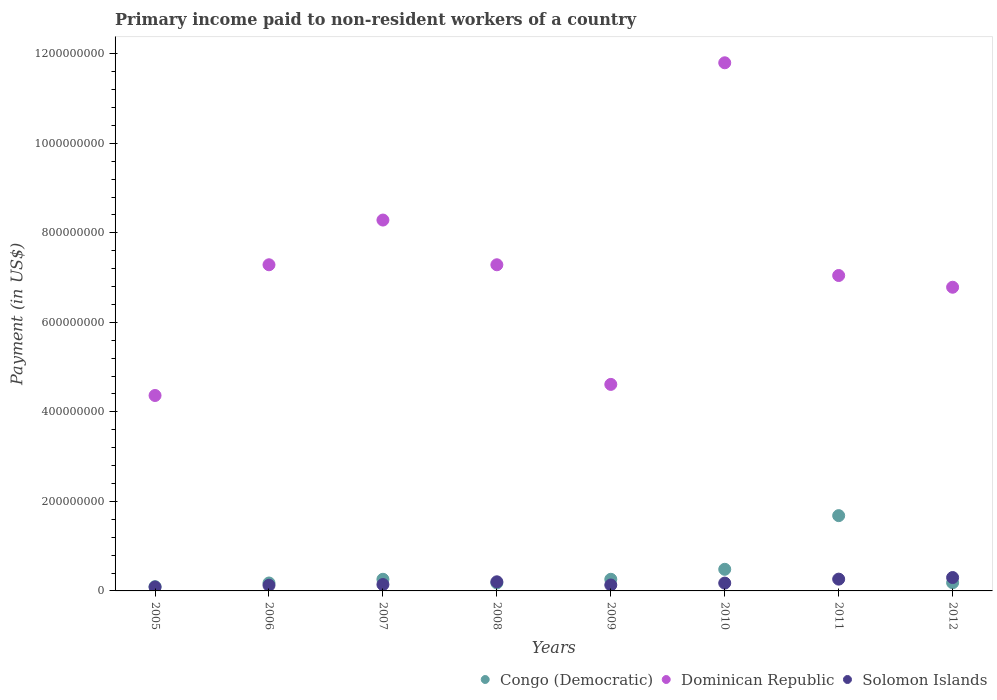How many different coloured dotlines are there?
Your answer should be very brief. 3. Is the number of dotlines equal to the number of legend labels?
Keep it short and to the point. Yes. What is the amount paid to workers in Dominican Republic in 2009?
Provide a short and direct response. 4.61e+08. Across all years, what is the maximum amount paid to workers in Dominican Republic?
Your answer should be very brief. 1.18e+09. Across all years, what is the minimum amount paid to workers in Congo (Democratic)?
Keep it short and to the point. 9.50e+06. In which year was the amount paid to workers in Solomon Islands minimum?
Ensure brevity in your answer.  2005. What is the total amount paid to workers in Dominican Republic in the graph?
Provide a short and direct response. 5.75e+09. What is the difference between the amount paid to workers in Solomon Islands in 2005 and that in 2011?
Offer a very short reply. -1.76e+07. What is the difference between the amount paid to workers in Congo (Democratic) in 2005 and the amount paid to workers in Dominican Republic in 2007?
Provide a short and direct response. -8.19e+08. What is the average amount paid to workers in Congo (Democratic) per year?
Make the answer very short. 4.15e+07. In the year 2009, what is the difference between the amount paid to workers in Solomon Islands and amount paid to workers in Dominican Republic?
Give a very brief answer. -4.48e+08. In how many years, is the amount paid to workers in Dominican Republic greater than 880000000 US$?
Offer a terse response. 1. What is the ratio of the amount paid to workers in Congo (Democratic) in 2009 to that in 2012?
Offer a very short reply. 1.42. Is the difference between the amount paid to workers in Solomon Islands in 2006 and 2007 greater than the difference between the amount paid to workers in Dominican Republic in 2006 and 2007?
Provide a succinct answer. Yes. What is the difference between the highest and the second highest amount paid to workers in Dominican Republic?
Keep it short and to the point. 3.51e+08. What is the difference between the highest and the lowest amount paid to workers in Dominican Republic?
Offer a terse response. 7.43e+08. Is the sum of the amount paid to workers in Dominican Republic in 2011 and 2012 greater than the maximum amount paid to workers in Solomon Islands across all years?
Make the answer very short. Yes. Does the amount paid to workers in Congo (Democratic) monotonically increase over the years?
Ensure brevity in your answer.  No. Is the amount paid to workers in Dominican Republic strictly greater than the amount paid to workers in Solomon Islands over the years?
Provide a short and direct response. Yes. Is the amount paid to workers in Dominican Republic strictly less than the amount paid to workers in Congo (Democratic) over the years?
Your response must be concise. No. How many dotlines are there?
Keep it short and to the point. 3. What is the difference between two consecutive major ticks on the Y-axis?
Keep it short and to the point. 2.00e+08. Does the graph contain any zero values?
Your answer should be compact. No. Where does the legend appear in the graph?
Your answer should be very brief. Bottom right. How many legend labels are there?
Your answer should be very brief. 3. How are the legend labels stacked?
Your answer should be very brief. Horizontal. What is the title of the graph?
Your answer should be compact. Primary income paid to non-resident workers of a country. Does "Gabon" appear as one of the legend labels in the graph?
Provide a succinct answer. No. What is the label or title of the X-axis?
Ensure brevity in your answer.  Years. What is the label or title of the Y-axis?
Ensure brevity in your answer.  Payment (in US$). What is the Payment (in US$) of Congo (Democratic) in 2005?
Make the answer very short. 9.50e+06. What is the Payment (in US$) of Dominican Republic in 2005?
Give a very brief answer. 4.37e+08. What is the Payment (in US$) in Solomon Islands in 2005?
Provide a short and direct response. 8.69e+06. What is the Payment (in US$) in Congo (Democratic) in 2006?
Provide a short and direct response. 1.77e+07. What is the Payment (in US$) of Dominican Republic in 2006?
Offer a terse response. 7.29e+08. What is the Payment (in US$) of Solomon Islands in 2006?
Your response must be concise. 1.26e+07. What is the Payment (in US$) of Congo (Democratic) in 2007?
Offer a very short reply. 2.60e+07. What is the Payment (in US$) in Dominican Republic in 2007?
Offer a very short reply. 8.29e+08. What is the Payment (in US$) of Solomon Islands in 2007?
Ensure brevity in your answer.  1.43e+07. What is the Payment (in US$) in Congo (Democratic) in 2008?
Keep it short and to the point. 1.78e+07. What is the Payment (in US$) of Dominican Republic in 2008?
Provide a succinct answer. 7.29e+08. What is the Payment (in US$) of Solomon Islands in 2008?
Provide a succinct answer. 2.04e+07. What is the Payment (in US$) in Congo (Democratic) in 2009?
Give a very brief answer. 2.60e+07. What is the Payment (in US$) of Dominican Republic in 2009?
Provide a succinct answer. 4.61e+08. What is the Payment (in US$) in Solomon Islands in 2009?
Keep it short and to the point. 1.32e+07. What is the Payment (in US$) in Congo (Democratic) in 2010?
Your response must be concise. 4.83e+07. What is the Payment (in US$) in Dominican Republic in 2010?
Offer a terse response. 1.18e+09. What is the Payment (in US$) of Solomon Islands in 2010?
Make the answer very short. 1.75e+07. What is the Payment (in US$) of Congo (Democratic) in 2011?
Your response must be concise. 1.68e+08. What is the Payment (in US$) in Dominican Republic in 2011?
Ensure brevity in your answer.  7.05e+08. What is the Payment (in US$) in Solomon Islands in 2011?
Your answer should be very brief. 2.63e+07. What is the Payment (in US$) of Congo (Democratic) in 2012?
Offer a terse response. 1.83e+07. What is the Payment (in US$) in Dominican Republic in 2012?
Provide a succinct answer. 6.78e+08. What is the Payment (in US$) in Solomon Islands in 2012?
Ensure brevity in your answer.  2.99e+07. Across all years, what is the maximum Payment (in US$) in Congo (Democratic)?
Give a very brief answer. 1.68e+08. Across all years, what is the maximum Payment (in US$) of Dominican Republic?
Give a very brief answer. 1.18e+09. Across all years, what is the maximum Payment (in US$) in Solomon Islands?
Offer a terse response. 2.99e+07. Across all years, what is the minimum Payment (in US$) of Congo (Democratic)?
Make the answer very short. 9.50e+06. Across all years, what is the minimum Payment (in US$) of Dominican Republic?
Offer a terse response. 4.37e+08. Across all years, what is the minimum Payment (in US$) of Solomon Islands?
Make the answer very short. 8.69e+06. What is the total Payment (in US$) in Congo (Democratic) in the graph?
Ensure brevity in your answer.  3.32e+08. What is the total Payment (in US$) in Dominican Republic in the graph?
Provide a succinct answer. 5.75e+09. What is the total Payment (in US$) of Solomon Islands in the graph?
Your response must be concise. 1.43e+08. What is the difference between the Payment (in US$) in Congo (Democratic) in 2005 and that in 2006?
Keep it short and to the point. -8.20e+06. What is the difference between the Payment (in US$) of Dominican Republic in 2005 and that in 2006?
Offer a terse response. -2.92e+08. What is the difference between the Payment (in US$) of Solomon Islands in 2005 and that in 2006?
Your response must be concise. -3.88e+06. What is the difference between the Payment (in US$) of Congo (Democratic) in 2005 and that in 2007?
Offer a terse response. -1.65e+07. What is the difference between the Payment (in US$) in Dominican Republic in 2005 and that in 2007?
Offer a terse response. -3.92e+08. What is the difference between the Payment (in US$) in Solomon Islands in 2005 and that in 2007?
Provide a short and direct response. -5.57e+06. What is the difference between the Payment (in US$) of Congo (Democratic) in 2005 and that in 2008?
Make the answer very short. -8.30e+06. What is the difference between the Payment (in US$) of Dominican Republic in 2005 and that in 2008?
Keep it short and to the point. -2.92e+08. What is the difference between the Payment (in US$) of Solomon Islands in 2005 and that in 2008?
Offer a terse response. -1.17e+07. What is the difference between the Payment (in US$) of Congo (Democratic) in 2005 and that in 2009?
Keep it short and to the point. -1.65e+07. What is the difference between the Payment (in US$) in Dominican Republic in 2005 and that in 2009?
Provide a short and direct response. -2.48e+07. What is the difference between the Payment (in US$) in Solomon Islands in 2005 and that in 2009?
Provide a succinct answer. -4.55e+06. What is the difference between the Payment (in US$) of Congo (Democratic) in 2005 and that in 2010?
Provide a short and direct response. -3.88e+07. What is the difference between the Payment (in US$) of Dominican Republic in 2005 and that in 2010?
Your answer should be very brief. -7.43e+08. What is the difference between the Payment (in US$) of Solomon Islands in 2005 and that in 2010?
Provide a succinct answer. -8.81e+06. What is the difference between the Payment (in US$) in Congo (Democratic) in 2005 and that in 2011?
Give a very brief answer. -1.59e+08. What is the difference between the Payment (in US$) of Dominican Republic in 2005 and that in 2011?
Keep it short and to the point. -2.68e+08. What is the difference between the Payment (in US$) of Solomon Islands in 2005 and that in 2011?
Provide a succinct answer. -1.76e+07. What is the difference between the Payment (in US$) of Congo (Democratic) in 2005 and that in 2012?
Keep it short and to the point. -8.76e+06. What is the difference between the Payment (in US$) of Dominican Republic in 2005 and that in 2012?
Your answer should be compact. -2.42e+08. What is the difference between the Payment (in US$) of Solomon Islands in 2005 and that in 2012?
Ensure brevity in your answer.  -2.12e+07. What is the difference between the Payment (in US$) in Congo (Democratic) in 2006 and that in 2007?
Give a very brief answer. -8.30e+06. What is the difference between the Payment (in US$) of Dominican Republic in 2006 and that in 2007?
Provide a succinct answer. -9.99e+07. What is the difference between the Payment (in US$) of Solomon Islands in 2006 and that in 2007?
Make the answer very short. -1.69e+06. What is the difference between the Payment (in US$) in Solomon Islands in 2006 and that in 2008?
Your answer should be very brief. -7.80e+06. What is the difference between the Payment (in US$) in Congo (Democratic) in 2006 and that in 2009?
Offer a terse response. -8.30e+06. What is the difference between the Payment (in US$) of Dominican Republic in 2006 and that in 2009?
Offer a terse response. 2.67e+08. What is the difference between the Payment (in US$) of Solomon Islands in 2006 and that in 2009?
Give a very brief answer. -6.69e+05. What is the difference between the Payment (in US$) in Congo (Democratic) in 2006 and that in 2010?
Your answer should be very brief. -3.06e+07. What is the difference between the Payment (in US$) of Dominican Republic in 2006 and that in 2010?
Offer a terse response. -4.51e+08. What is the difference between the Payment (in US$) in Solomon Islands in 2006 and that in 2010?
Provide a succinct answer. -4.93e+06. What is the difference between the Payment (in US$) of Congo (Democratic) in 2006 and that in 2011?
Keep it short and to the point. -1.50e+08. What is the difference between the Payment (in US$) of Dominican Republic in 2006 and that in 2011?
Provide a succinct answer. 2.40e+07. What is the difference between the Payment (in US$) of Solomon Islands in 2006 and that in 2011?
Give a very brief answer. -1.38e+07. What is the difference between the Payment (in US$) of Congo (Democratic) in 2006 and that in 2012?
Give a very brief answer. -5.62e+05. What is the difference between the Payment (in US$) of Dominican Republic in 2006 and that in 2012?
Give a very brief answer. 5.02e+07. What is the difference between the Payment (in US$) in Solomon Islands in 2006 and that in 2012?
Keep it short and to the point. -1.73e+07. What is the difference between the Payment (in US$) of Congo (Democratic) in 2007 and that in 2008?
Your answer should be very brief. 8.20e+06. What is the difference between the Payment (in US$) of Dominican Republic in 2007 and that in 2008?
Offer a very short reply. 9.99e+07. What is the difference between the Payment (in US$) of Solomon Islands in 2007 and that in 2008?
Make the answer very short. -6.11e+06. What is the difference between the Payment (in US$) of Congo (Democratic) in 2007 and that in 2009?
Keep it short and to the point. 0. What is the difference between the Payment (in US$) in Dominican Republic in 2007 and that in 2009?
Your response must be concise. 3.67e+08. What is the difference between the Payment (in US$) of Solomon Islands in 2007 and that in 2009?
Your answer should be compact. 1.02e+06. What is the difference between the Payment (in US$) in Congo (Democratic) in 2007 and that in 2010?
Make the answer very short. -2.23e+07. What is the difference between the Payment (in US$) of Dominican Republic in 2007 and that in 2010?
Your response must be concise. -3.51e+08. What is the difference between the Payment (in US$) in Solomon Islands in 2007 and that in 2010?
Your answer should be very brief. -3.24e+06. What is the difference between the Payment (in US$) of Congo (Democratic) in 2007 and that in 2011?
Offer a very short reply. -1.42e+08. What is the difference between the Payment (in US$) of Dominican Republic in 2007 and that in 2011?
Make the answer very short. 1.24e+08. What is the difference between the Payment (in US$) of Solomon Islands in 2007 and that in 2011?
Provide a short and direct response. -1.21e+07. What is the difference between the Payment (in US$) of Congo (Democratic) in 2007 and that in 2012?
Ensure brevity in your answer.  7.74e+06. What is the difference between the Payment (in US$) in Dominican Republic in 2007 and that in 2012?
Your response must be concise. 1.50e+08. What is the difference between the Payment (in US$) of Solomon Islands in 2007 and that in 2012?
Give a very brief answer. -1.56e+07. What is the difference between the Payment (in US$) in Congo (Democratic) in 2008 and that in 2009?
Ensure brevity in your answer.  -8.20e+06. What is the difference between the Payment (in US$) in Dominican Republic in 2008 and that in 2009?
Keep it short and to the point. 2.67e+08. What is the difference between the Payment (in US$) in Solomon Islands in 2008 and that in 2009?
Make the answer very short. 7.13e+06. What is the difference between the Payment (in US$) of Congo (Democratic) in 2008 and that in 2010?
Offer a terse response. -3.05e+07. What is the difference between the Payment (in US$) of Dominican Republic in 2008 and that in 2010?
Your answer should be very brief. -4.51e+08. What is the difference between the Payment (in US$) of Solomon Islands in 2008 and that in 2010?
Give a very brief answer. 2.87e+06. What is the difference between the Payment (in US$) in Congo (Democratic) in 2008 and that in 2011?
Your answer should be very brief. -1.50e+08. What is the difference between the Payment (in US$) of Dominican Republic in 2008 and that in 2011?
Provide a short and direct response. 2.40e+07. What is the difference between the Payment (in US$) of Solomon Islands in 2008 and that in 2011?
Keep it short and to the point. -5.95e+06. What is the difference between the Payment (in US$) in Congo (Democratic) in 2008 and that in 2012?
Your response must be concise. -4.62e+05. What is the difference between the Payment (in US$) of Dominican Republic in 2008 and that in 2012?
Your response must be concise. 5.02e+07. What is the difference between the Payment (in US$) in Solomon Islands in 2008 and that in 2012?
Give a very brief answer. -9.53e+06. What is the difference between the Payment (in US$) of Congo (Democratic) in 2009 and that in 2010?
Provide a short and direct response. -2.23e+07. What is the difference between the Payment (in US$) of Dominican Republic in 2009 and that in 2010?
Your answer should be compact. -7.19e+08. What is the difference between the Payment (in US$) of Solomon Islands in 2009 and that in 2010?
Ensure brevity in your answer.  -4.26e+06. What is the difference between the Payment (in US$) in Congo (Democratic) in 2009 and that in 2011?
Your answer should be very brief. -1.42e+08. What is the difference between the Payment (in US$) of Dominican Republic in 2009 and that in 2011?
Give a very brief answer. -2.43e+08. What is the difference between the Payment (in US$) of Solomon Islands in 2009 and that in 2011?
Keep it short and to the point. -1.31e+07. What is the difference between the Payment (in US$) of Congo (Democratic) in 2009 and that in 2012?
Offer a terse response. 7.74e+06. What is the difference between the Payment (in US$) in Dominican Republic in 2009 and that in 2012?
Offer a terse response. -2.17e+08. What is the difference between the Payment (in US$) in Solomon Islands in 2009 and that in 2012?
Give a very brief answer. -1.67e+07. What is the difference between the Payment (in US$) in Congo (Democratic) in 2010 and that in 2011?
Ensure brevity in your answer.  -1.20e+08. What is the difference between the Payment (in US$) in Dominican Republic in 2010 and that in 2011?
Offer a very short reply. 4.75e+08. What is the difference between the Payment (in US$) in Solomon Islands in 2010 and that in 2011?
Give a very brief answer. -8.82e+06. What is the difference between the Payment (in US$) of Congo (Democratic) in 2010 and that in 2012?
Your response must be concise. 3.00e+07. What is the difference between the Payment (in US$) in Dominican Republic in 2010 and that in 2012?
Provide a short and direct response. 5.01e+08. What is the difference between the Payment (in US$) in Solomon Islands in 2010 and that in 2012?
Offer a terse response. -1.24e+07. What is the difference between the Payment (in US$) in Congo (Democratic) in 2011 and that in 2012?
Ensure brevity in your answer.  1.50e+08. What is the difference between the Payment (in US$) of Dominican Republic in 2011 and that in 2012?
Give a very brief answer. 2.62e+07. What is the difference between the Payment (in US$) of Solomon Islands in 2011 and that in 2012?
Offer a terse response. -3.58e+06. What is the difference between the Payment (in US$) in Congo (Democratic) in 2005 and the Payment (in US$) in Dominican Republic in 2006?
Offer a very short reply. -7.19e+08. What is the difference between the Payment (in US$) of Congo (Democratic) in 2005 and the Payment (in US$) of Solomon Islands in 2006?
Offer a very short reply. -3.07e+06. What is the difference between the Payment (in US$) of Dominican Republic in 2005 and the Payment (in US$) of Solomon Islands in 2006?
Ensure brevity in your answer.  4.24e+08. What is the difference between the Payment (in US$) in Congo (Democratic) in 2005 and the Payment (in US$) in Dominican Republic in 2007?
Make the answer very short. -8.19e+08. What is the difference between the Payment (in US$) of Congo (Democratic) in 2005 and the Payment (in US$) of Solomon Islands in 2007?
Provide a short and direct response. -4.77e+06. What is the difference between the Payment (in US$) in Dominican Republic in 2005 and the Payment (in US$) in Solomon Islands in 2007?
Your answer should be compact. 4.22e+08. What is the difference between the Payment (in US$) of Congo (Democratic) in 2005 and the Payment (in US$) of Dominican Republic in 2008?
Keep it short and to the point. -7.19e+08. What is the difference between the Payment (in US$) in Congo (Democratic) in 2005 and the Payment (in US$) in Solomon Islands in 2008?
Your answer should be very brief. -1.09e+07. What is the difference between the Payment (in US$) in Dominican Republic in 2005 and the Payment (in US$) in Solomon Islands in 2008?
Offer a terse response. 4.16e+08. What is the difference between the Payment (in US$) in Congo (Democratic) in 2005 and the Payment (in US$) in Dominican Republic in 2009?
Keep it short and to the point. -4.52e+08. What is the difference between the Payment (in US$) in Congo (Democratic) in 2005 and the Payment (in US$) in Solomon Islands in 2009?
Provide a succinct answer. -3.74e+06. What is the difference between the Payment (in US$) in Dominican Republic in 2005 and the Payment (in US$) in Solomon Islands in 2009?
Your response must be concise. 4.23e+08. What is the difference between the Payment (in US$) in Congo (Democratic) in 2005 and the Payment (in US$) in Dominican Republic in 2010?
Offer a terse response. -1.17e+09. What is the difference between the Payment (in US$) in Congo (Democratic) in 2005 and the Payment (in US$) in Solomon Islands in 2010?
Provide a succinct answer. -8.01e+06. What is the difference between the Payment (in US$) in Dominican Republic in 2005 and the Payment (in US$) in Solomon Islands in 2010?
Keep it short and to the point. 4.19e+08. What is the difference between the Payment (in US$) in Congo (Democratic) in 2005 and the Payment (in US$) in Dominican Republic in 2011?
Ensure brevity in your answer.  -6.95e+08. What is the difference between the Payment (in US$) in Congo (Democratic) in 2005 and the Payment (in US$) in Solomon Islands in 2011?
Make the answer very short. -1.68e+07. What is the difference between the Payment (in US$) in Dominican Republic in 2005 and the Payment (in US$) in Solomon Islands in 2011?
Provide a succinct answer. 4.10e+08. What is the difference between the Payment (in US$) in Congo (Democratic) in 2005 and the Payment (in US$) in Dominican Republic in 2012?
Ensure brevity in your answer.  -6.69e+08. What is the difference between the Payment (in US$) of Congo (Democratic) in 2005 and the Payment (in US$) of Solomon Islands in 2012?
Your response must be concise. -2.04e+07. What is the difference between the Payment (in US$) of Dominican Republic in 2005 and the Payment (in US$) of Solomon Islands in 2012?
Make the answer very short. 4.07e+08. What is the difference between the Payment (in US$) of Congo (Democratic) in 2006 and the Payment (in US$) of Dominican Republic in 2007?
Offer a very short reply. -8.11e+08. What is the difference between the Payment (in US$) in Congo (Democratic) in 2006 and the Payment (in US$) in Solomon Islands in 2007?
Offer a terse response. 3.43e+06. What is the difference between the Payment (in US$) in Dominican Republic in 2006 and the Payment (in US$) in Solomon Islands in 2007?
Give a very brief answer. 7.14e+08. What is the difference between the Payment (in US$) of Congo (Democratic) in 2006 and the Payment (in US$) of Dominican Republic in 2008?
Provide a short and direct response. -7.11e+08. What is the difference between the Payment (in US$) of Congo (Democratic) in 2006 and the Payment (in US$) of Solomon Islands in 2008?
Provide a succinct answer. -2.67e+06. What is the difference between the Payment (in US$) in Dominican Republic in 2006 and the Payment (in US$) in Solomon Islands in 2008?
Give a very brief answer. 7.08e+08. What is the difference between the Payment (in US$) in Congo (Democratic) in 2006 and the Payment (in US$) in Dominican Republic in 2009?
Offer a very short reply. -4.44e+08. What is the difference between the Payment (in US$) of Congo (Democratic) in 2006 and the Payment (in US$) of Solomon Islands in 2009?
Offer a very short reply. 4.46e+06. What is the difference between the Payment (in US$) of Dominican Republic in 2006 and the Payment (in US$) of Solomon Islands in 2009?
Provide a short and direct response. 7.15e+08. What is the difference between the Payment (in US$) in Congo (Democratic) in 2006 and the Payment (in US$) in Dominican Republic in 2010?
Your response must be concise. -1.16e+09. What is the difference between the Payment (in US$) in Congo (Democratic) in 2006 and the Payment (in US$) in Solomon Islands in 2010?
Your answer should be compact. 1.95e+05. What is the difference between the Payment (in US$) of Dominican Republic in 2006 and the Payment (in US$) of Solomon Islands in 2010?
Give a very brief answer. 7.11e+08. What is the difference between the Payment (in US$) in Congo (Democratic) in 2006 and the Payment (in US$) in Dominican Republic in 2011?
Provide a succinct answer. -6.87e+08. What is the difference between the Payment (in US$) in Congo (Democratic) in 2006 and the Payment (in US$) in Solomon Islands in 2011?
Your response must be concise. -8.62e+06. What is the difference between the Payment (in US$) in Dominican Republic in 2006 and the Payment (in US$) in Solomon Islands in 2011?
Provide a succinct answer. 7.02e+08. What is the difference between the Payment (in US$) in Congo (Democratic) in 2006 and the Payment (in US$) in Dominican Republic in 2012?
Your answer should be compact. -6.61e+08. What is the difference between the Payment (in US$) of Congo (Democratic) in 2006 and the Payment (in US$) of Solomon Islands in 2012?
Provide a succinct answer. -1.22e+07. What is the difference between the Payment (in US$) of Dominican Republic in 2006 and the Payment (in US$) of Solomon Islands in 2012?
Keep it short and to the point. 6.99e+08. What is the difference between the Payment (in US$) of Congo (Democratic) in 2007 and the Payment (in US$) of Dominican Republic in 2008?
Your answer should be very brief. -7.03e+08. What is the difference between the Payment (in US$) of Congo (Democratic) in 2007 and the Payment (in US$) of Solomon Islands in 2008?
Offer a very short reply. 5.63e+06. What is the difference between the Payment (in US$) in Dominican Republic in 2007 and the Payment (in US$) in Solomon Islands in 2008?
Offer a very short reply. 8.08e+08. What is the difference between the Payment (in US$) of Congo (Democratic) in 2007 and the Payment (in US$) of Dominican Republic in 2009?
Your answer should be compact. -4.35e+08. What is the difference between the Payment (in US$) of Congo (Democratic) in 2007 and the Payment (in US$) of Solomon Islands in 2009?
Your answer should be very brief. 1.28e+07. What is the difference between the Payment (in US$) in Dominican Republic in 2007 and the Payment (in US$) in Solomon Islands in 2009?
Provide a short and direct response. 8.15e+08. What is the difference between the Payment (in US$) of Congo (Democratic) in 2007 and the Payment (in US$) of Dominican Republic in 2010?
Provide a short and direct response. -1.15e+09. What is the difference between the Payment (in US$) in Congo (Democratic) in 2007 and the Payment (in US$) in Solomon Islands in 2010?
Your response must be concise. 8.49e+06. What is the difference between the Payment (in US$) in Dominican Republic in 2007 and the Payment (in US$) in Solomon Islands in 2010?
Offer a terse response. 8.11e+08. What is the difference between the Payment (in US$) in Congo (Democratic) in 2007 and the Payment (in US$) in Dominican Republic in 2011?
Keep it short and to the point. -6.79e+08. What is the difference between the Payment (in US$) in Congo (Democratic) in 2007 and the Payment (in US$) in Solomon Islands in 2011?
Make the answer very short. -3.24e+05. What is the difference between the Payment (in US$) in Dominican Republic in 2007 and the Payment (in US$) in Solomon Islands in 2011?
Offer a terse response. 8.02e+08. What is the difference between the Payment (in US$) of Congo (Democratic) in 2007 and the Payment (in US$) of Dominican Republic in 2012?
Offer a very short reply. -6.52e+08. What is the difference between the Payment (in US$) of Congo (Democratic) in 2007 and the Payment (in US$) of Solomon Islands in 2012?
Your answer should be compact. -3.90e+06. What is the difference between the Payment (in US$) of Dominican Republic in 2007 and the Payment (in US$) of Solomon Islands in 2012?
Offer a terse response. 7.99e+08. What is the difference between the Payment (in US$) of Congo (Democratic) in 2008 and the Payment (in US$) of Dominican Republic in 2009?
Your answer should be very brief. -4.44e+08. What is the difference between the Payment (in US$) of Congo (Democratic) in 2008 and the Payment (in US$) of Solomon Islands in 2009?
Provide a succinct answer. 4.56e+06. What is the difference between the Payment (in US$) in Dominican Republic in 2008 and the Payment (in US$) in Solomon Islands in 2009?
Your answer should be very brief. 7.15e+08. What is the difference between the Payment (in US$) in Congo (Democratic) in 2008 and the Payment (in US$) in Dominican Republic in 2010?
Your answer should be very brief. -1.16e+09. What is the difference between the Payment (in US$) of Congo (Democratic) in 2008 and the Payment (in US$) of Solomon Islands in 2010?
Offer a very short reply. 2.95e+05. What is the difference between the Payment (in US$) of Dominican Republic in 2008 and the Payment (in US$) of Solomon Islands in 2010?
Provide a succinct answer. 7.11e+08. What is the difference between the Payment (in US$) of Congo (Democratic) in 2008 and the Payment (in US$) of Dominican Republic in 2011?
Make the answer very short. -6.87e+08. What is the difference between the Payment (in US$) in Congo (Democratic) in 2008 and the Payment (in US$) in Solomon Islands in 2011?
Offer a terse response. -8.52e+06. What is the difference between the Payment (in US$) in Dominican Republic in 2008 and the Payment (in US$) in Solomon Islands in 2011?
Provide a short and direct response. 7.02e+08. What is the difference between the Payment (in US$) in Congo (Democratic) in 2008 and the Payment (in US$) in Dominican Republic in 2012?
Make the answer very short. -6.61e+08. What is the difference between the Payment (in US$) in Congo (Democratic) in 2008 and the Payment (in US$) in Solomon Islands in 2012?
Provide a short and direct response. -1.21e+07. What is the difference between the Payment (in US$) in Dominican Republic in 2008 and the Payment (in US$) in Solomon Islands in 2012?
Your answer should be very brief. 6.99e+08. What is the difference between the Payment (in US$) in Congo (Democratic) in 2009 and the Payment (in US$) in Dominican Republic in 2010?
Offer a terse response. -1.15e+09. What is the difference between the Payment (in US$) of Congo (Democratic) in 2009 and the Payment (in US$) of Solomon Islands in 2010?
Ensure brevity in your answer.  8.49e+06. What is the difference between the Payment (in US$) of Dominican Republic in 2009 and the Payment (in US$) of Solomon Islands in 2010?
Your answer should be very brief. 4.44e+08. What is the difference between the Payment (in US$) in Congo (Democratic) in 2009 and the Payment (in US$) in Dominican Republic in 2011?
Your response must be concise. -6.79e+08. What is the difference between the Payment (in US$) of Congo (Democratic) in 2009 and the Payment (in US$) of Solomon Islands in 2011?
Give a very brief answer. -3.24e+05. What is the difference between the Payment (in US$) of Dominican Republic in 2009 and the Payment (in US$) of Solomon Islands in 2011?
Your response must be concise. 4.35e+08. What is the difference between the Payment (in US$) in Congo (Democratic) in 2009 and the Payment (in US$) in Dominican Republic in 2012?
Keep it short and to the point. -6.52e+08. What is the difference between the Payment (in US$) of Congo (Democratic) in 2009 and the Payment (in US$) of Solomon Islands in 2012?
Make the answer very short. -3.90e+06. What is the difference between the Payment (in US$) of Dominican Republic in 2009 and the Payment (in US$) of Solomon Islands in 2012?
Provide a succinct answer. 4.31e+08. What is the difference between the Payment (in US$) in Congo (Democratic) in 2010 and the Payment (in US$) in Dominican Republic in 2011?
Offer a terse response. -6.56e+08. What is the difference between the Payment (in US$) in Congo (Democratic) in 2010 and the Payment (in US$) in Solomon Islands in 2011?
Offer a terse response. 2.20e+07. What is the difference between the Payment (in US$) of Dominican Republic in 2010 and the Payment (in US$) of Solomon Islands in 2011?
Make the answer very short. 1.15e+09. What is the difference between the Payment (in US$) in Congo (Democratic) in 2010 and the Payment (in US$) in Dominican Republic in 2012?
Your response must be concise. -6.30e+08. What is the difference between the Payment (in US$) of Congo (Democratic) in 2010 and the Payment (in US$) of Solomon Islands in 2012?
Provide a short and direct response. 1.84e+07. What is the difference between the Payment (in US$) of Dominican Republic in 2010 and the Payment (in US$) of Solomon Islands in 2012?
Offer a terse response. 1.15e+09. What is the difference between the Payment (in US$) of Congo (Democratic) in 2011 and the Payment (in US$) of Dominican Republic in 2012?
Ensure brevity in your answer.  -5.10e+08. What is the difference between the Payment (in US$) of Congo (Democratic) in 2011 and the Payment (in US$) of Solomon Islands in 2012?
Your answer should be very brief. 1.38e+08. What is the difference between the Payment (in US$) in Dominican Republic in 2011 and the Payment (in US$) in Solomon Islands in 2012?
Provide a succinct answer. 6.75e+08. What is the average Payment (in US$) in Congo (Democratic) per year?
Give a very brief answer. 4.15e+07. What is the average Payment (in US$) in Dominican Republic per year?
Make the answer very short. 7.18e+08. What is the average Payment (in US$) of Solomon Islands per year?
Give a very brief answer. 1.79e+07. In the year 2005, what is the difference between the Payment (in US$) of Congo (Democratic) and Payment (in US$) of Dominican Republic?
Provide a succinct answer. -4.27e+08. In the year 2005, what is the difference between the Payment (in US$) in Congo (Democratic) and Payment (in US$) in Solomon Islands?
Ensure brevity in your answer.  8.08e+05. In the year 2005, what is the difference between the Payment (in US$) of Dominican Republic and Payment (in US$) of Solomon Islands?
Your response must be concise. 4.28e+08. In the year 2006, what is the difference between the Payment (in US$) of Congo (Democratic) and Payment (in US$) of Dominican Republic?
Your answer should be compact. -7.11e+08. In the year 2006, what is the difference between the Payment (in US$) of Congo (Democratic) and Payment (in US$) of Solomon Islands?
Give a very brief answer. 5.13e+06. In the year 2006, what is the difference between the Payment (in US$) of Dominican Republic and Payment (in US$) of Solomon Islands?
Your answer should be compact. 7.16e+08. In the year 2007, what is the difference between the Payment (in US$) of Congo (Democratic) and Payment (in US$) of Dominican Republic?
Offer a very short reply. -8.03e+08. In the year 2007, what is the difference between the Payment (in US$) in Congo (Democratic) and Payment (in US$) in Solomon Islands?
Make the answer very short. 1.17e+07. In the year 2007, what is the difference between the Payment (in US$) in Dominican Republic and Payment (in US$) in Solomon Islands?
Give a very brief answer. 8.14e+08. In the year 2008, what is the difference between the Payment (in US$) in Congo (Democratic) and Payment (in US$) in Dominican Republic?
Your answer should be compact. -7.11e+08. In the year 2008, what is the difference between the Payment (in US$) of Congo (Democratic) and Payment (in US$) of Solomon Islands?
Your answer should be very brief. -2.57e+06. In the year 2008, what is the difference between the Payment (in US$) of Dominican Republic and Payment (in US$) of Solomon Islands?
Keep it short and to the point. 7.08e+08. In the year 2009, what is the difference between the Payment (in US$) in Congo (Democratic) and Payment (in US$) in Dominican Republic?
Your answer should be very brief. -4.35e+08. In the year 2009, what is the difference between the Payment (in US$) of Congo (Democratic) and Payment (in US$) of Solomon Islands?
Keep it short and to the point. 1.28e+07. In the year 2009, what is the difference between the Payment (in US$) of Dominican Republic and Payment (in US$) of Solomon Islands?
Provide a short and direct response. 4.48e+08. In the year 2010, what is the difference between the Payment (in US$) of Congo (Democratic) and Payment (in US$) of Dominican Republic?
Offer a terse response. -1.13e+09. In the year 2010, what is the difference between the Payment (in US$) of Congo (Democratic) and Payment (in US$) of Solomon Islands?
Your response must be concise. 3.08e+07. In the year 2010, what is the difference between the Payment (in US$) of Dominican Republic and Payment (in US$) of Solomon Islands?
Your answer should be very brief. 1.16e+09. In the year 2011, what is the difference between the Payment (in US$) in Congo (Democratic) and Payment (in US$) in Dominican Republic?
Offer a very short reply. -5.36e+08. In the year 2011, what is the difference between the Payment (in US$) of Congo (Democratic) and Payment (in US$) of Solomon Islands?
Ensure brevity in your answer.  1.42e+08. In the year 2011, what is the difference between the Payment (in US$) of Dominican Republic and Payment (in US$) of Solomon Islands?
Offer a terse response. 6.78e+08. In the year 2012, what is the difference between the Payment (in US$) of Congo (Democratic) and Payment (in US$) of Dominican Republic?
Offer a very short reply. -6.60e+08. In the year 2012, what is the difference between the Payment (in US$) in Congo (Democratic) and Payment (in US$) in Solomon Islands?
Your response must be concise. -1.16e+07. In the year 2012, what is the difference between the Payment (in US$) of Dominican Republic and Payment (in US$) of Solomon Islands?
Provide a short and direct response. 6.49e+08. What is the ratio of the Payment (in US$) of Congo (Democratic) in 2005 to that in 2006?
Offer a terse response. 0.54. What is the ratio of the Payment (in US$) of Dominican Republic in 2005 to that in 2006?
Your answer should be compact. 0.6. What is the ratio of the Payment (in US$) of Solomon Islands in 2005 to that in 2006?
Your answer should be compact. 0.69. What is the ratio of the Payment (in US$) in Congo (Democratic) in 2005 to that in 2007?
Your answer should be very brief. 0.37. What is the ratio of the Payment (in US$) in Dominican Republic in 2005 to that in 2007?
Make the answer very short. 0.53. What is the ratio of the Payment (in US$) in Solomon Islands in 2005 to that in 2007?
Keep it short and to the point. 0.61. What is the ratio of the Payment (in US$) of Congo (Democratic) in 2005 to that in 2008?
Provide a short and direct response. 0.53. What is the ratio of the Payment (in US$) in Dominican Republic in 2005 to that in 2008?
Give a very brief answer. 0.6. What is the ratio of the Payment (in US$) in Solomon Islands in 2005 to that in 2008?
Offer a terse response. 0.43. What is the ratio of the Payment (in US$) in Congo (Democratic) in 2005 to that in 2009?
Give a very brief answer. 0.37. What is the ratio of the Payment (in US$) of Dominican Republic in 2005 to that in 2009?
Give a very brief answer. 0.95. What is the ratio of the Payment (in US$) of Solomon Islands in 2005 to that in 2009?
Offer a very short reply. 0.66. What is the ratio of the Payment (in US$) of Congo (Democratic) in 2005 to that in 2010?
Provide a succinct answer. 0.2. What is the ratio of the Payment (in US$) of Dominican Republic in 2005 to that in 2010?
Provide a short and direct response. 0.37. What is the ratio of the Payment (in US$) of Solomon Islands in 2005 to that in 2010?
Your response must be concise. 0.5. What is the ratio of the Payment (in US$) in Congo (Democratic) in 2005 to that in 2011?
Keep it short and to the point. 0.06. What is the ratio of the Payment (in US$) of Dominican Republic in 2005 to that in 2011?
Your response must be concise. 0.62. What is the ratio of the Payment (in US$) in Solomon Islands in 2005 to that in 2011?
Your answer should be compact. 0.33. What is the ratio of the Payment (in US$) in Congo (Democratic) in 2005 to that in 2012?
Give a very brief answer. 0.52. What is the ratio of the Payment (in US$) of Dominican Republic in 2005 to that in 2012?
Give a very brief answer. 0.64. What is the ratio of the Payment (in US$) of Solomon Islands in 2005 to that in 2012?
Provide a short and direct response. 0.29. What is the ratio of the Payment (in US$) in Congo (Democratic) in 2006 to that in 2007?
Provide a succinct answer. 0.68. What is the ratio of the Payment (in US$) of Dominican Republic in 2006 to that in 2007?
Offer a terse response. 0.88. What is the ratio of the Payment (in US$) in Solomon Islands in 2006 to that in 2007?
Make the answer very short. 0.88. What is the ratio of the Payment (in US$) in Solomon Islands in 2006 to that in 2008?
Give a very brief answer. 0.62. What is the ratio of the Payment (in US$) of Congo (Democratic) in 2006 to that in 2009?
Give a very brief answer. 0.68. What is the ratio of the Payment (in US$) in Dominican Republic in 2006 to that in 2009?
Provide a succinct answer. 1.58. What is the ratio of the Payment (in US$) in Solomon Islands in 2006 to that in 2009?
Offer a very short reply. 0.95. What is the ratio of the Payment (in US$) of Congo (Democratic) in 2006 to that in 2010?
Provide a short and direct response. 0.37. What is the ratio of the Payment (in US$) of Dominican Republic in 2006 to that in 2010?
Give a very brief answer. 0.62. What is the ratio of the Payment (in US$) of Solomon Islands in 2006 to that in 2010?
Your answer should be compact. 0.72. What is the ratio of the Payment (in US$) of Congo (Democratic) in 2006 to that in 2011?
Give a very brief answer. 0.11. What is the ratio of the Payment (in US$) of Dominican Republic in 2006 to that in 2011?
Offer a very short reply. 1.03. What is the ratio of the Payment (in US$) of Solomon Islands in 2006 to that in 2011?
Ensure brevity in your answer.  0.48. What is the ratio of the Payment (in US$) of Congo (Democratic) in 2006 to that in 2012?
Offer a very short reply. 0.97. What is the ratio of the Payment (in US$) of Dominican Republic in 2006 to that in 2012?
Your response must be concise. 1.07. What is the ratio of the Payment (in US$) of Solomon Islands in 2006 to that in 2012?
Keep it short and to the point. 0.42. What is the ratio of the Payment (in US$) of Congo (Democratic) in 2007 to that in 2008?
Provide a succinct answer. 1.46. What is the ratio of the Payment (in US$) of Dominican Republic in 2007 to that in 2008?
Keep it short and to the point. 1.14. What is the ratio of the Payment (in US$) of Solomon Islands in 2007 to that in 2008?
Your answer should be very brief. 0.7. What is the ratio of the Payment (in US$) of Dominican Republic in 2007 to that in 2009?
Your answer should be very brief. 1.8. What is the ratio of the Payment (in US$) in Solomon Islands in 2007 to that in 2009?
Offer a terse response. 1.08. What is the ratio of the Payment (in US$) in Congo (Democratic) in 2007 to that in 2010?
Your response must be concise. 0.54. What is the ratio of the Payment (in US$) of Dominican Republic in 2007 to that in 2010?
Your response must be concise. 0.7. What is the ratio of the Payment (in US$) of Solomon Islands in 2007 to that in 2010?
Your response must be concise. 0.81. What is the ratio of the Payment (in US$) of Congo (Democratic) in 2007 to that in 2011?
Make the answer very short. 0.15. What is the ratio of the Payment (in US$) of Dominican Republic in 2007 to that in 2011?
Offer a very short reply. 1.18. What is the ratio of the Payment (in US$) in Solomon Islands in 2007 to that in 2011?
Provide a short and direct response. 0.54. What is the ratio of the Payment (in US$) in Congo (Democratic) in 2007 to that in 2012?
Provide a succinct answer. 1.42. What is the ratio of the Payment (in US$) in Dominican Republic in 2007 to that in 2012?
Give a very brief answer. 1.22. What is the ratio of the Payment (in US$) of Solomon Islands in 2007 to that in 2012?
Your answer should be very brief. 0.48. What is the ratio of the Payment (in US$) of Congo (Democratic) in 2008 to that in 2009?
Give a very brief answer. 0.68. What is the ratio of the Payment (in US$) of Dominican Republic in 2008 to that in 2009?
Your answer should be compact. 1.58. What is the ratio of the Payment (in US$) of Solomon Islands in 2008 to that in 2009?
Give a very brief answer. 1.54. What is the ratio of the Payment (in US$) of Congo (Democratic) in 2008 to that in 2010?
Ensure brevity in your answer.  0.37. What is the ratio of the Payment (in US$) of Dominican Republic in 2008 to that in 2010?
Make the answer very short. 0.62. What is the ratio of the Payment (in US$) in Solomon Islands in 2008 to that in 2010?
Offer a terse response. 1.16. What is the ratio of the Payment (in US$) of Congo (Democratic) in 2008 to that in 2011?
Offer a very short reply. 0.11. What is the ratio of the Payment (in US$) in Dominican Republic in 2008 to that in 2011?
Give a very brief answer. 1.03. What is the ratio of the Payment (in US$) of Solomon Islands in 2008 to that in 2011?
Offer a terse response. 0.77. What is the ratio of the Payment (in US$) of Congo (Democratic) in 2008 to that in 2012?
Your answer should be compact. 0.97. What is the ratio of the Payment (in US$) in Dominican Republic in 2008 to that in 2012?
Provide a succinct answer. 1.07. What is the ratio of the Payment (in US$) in Solomon Islands in 2008 to that in 2012?
Provide a succinct answer. 0.68. What is the ratio of the Payment (in US$) in Congo (Democratic) in 2009 to that in 2010?
Your response must be concise. 0.54. What is the ratio of the Payment (in US$) of Dominican Republic in 2009 to that in 2010?
Your answer should be very brief. 0.39. What is the ratio of the Payment (in US$) in Solomon Islands in 2009 to that in 2010?
Your answer should be compact. 0.76. What is the ratio of the Payment (in US$) in Congo (Democratic) in 2009 to that in 2011?
Provide a short and direct response. 0.15. What is the ratio of the Payment (in US$) in Dominican Republic in 2009 to that in 2011?
Ensure brevity in your answer.  0.65. What is the ratio of the Payment (in US$) of Solomon Islands in 2009 to that in 2011?
Give a very brief answer. 0.5. What is the ratio of the Payment (in US$) in Congo (Democratic) in 2009 to that in 2012?
Offer a very short reply. 1.42. What is the ratio of the Payment (in US$) in Dominican Republic in 2009 to that in 2012?
Your response must be concise. 0.68. What is the ratio of the Payment (in US$) of Solomon Islands in 2009 to that in 2012?
Give a very brief answer. 0.44. What is the ratio of the Payment (in US$) of Congo (Democratic) in 2010 to that in 2011?
Provide a short and direct response. 0.29. What is the ratio of the Payment (in US$) of Dominican Republic in 2010 to that in 2011?
Provide a short and direct response. 1.67. What is the ratio of the Payment (in US$) of Solomon Islands in 2010 to that in 2011?
Your answer should be very brief. 0.67. What is the ratio of the Payment (in US$) of Congo (Democratic) in 2010 to that in 2012?
Your answer should be compact. 2.64. What is the ratio of the Payment (in US$) in Dominican Republic in 2010 to that in 2012?
Make the answer very short. 1.74. What is the ratio of the Payment (in US$) in Solomon Islands in 2010 to that in 2012?
Provide a short and direct response. 0.59. What is the ratio of the Payment (in US$) in Congo (Democratic) in 2011 to that in 2012?
Give a very brief answer. 9.21. What is the ratio of the Payment (in US$) in Dominican Republic in 2011 to that in 2012?
Offer a terse response. 1.04. What is the ratio of the Payment (in US$) in Solomon Islands in 2011 to that in 2012?
Provide a succinct answer. 0.88. What is the difference between the highest and the second highest Payment (in US$) of Congo (Democratic)?
Your response must be concise. 1.20e+08. What is the difference between the highest and the second highest Payment (in US$) of Dominican Republic?
Make the answer very short. 3.51e+08. What is the difference between the highest and the second highest Payment (in US$) of Solomon Islands?
Your answer should be very brief. 3.58e+06. What is the difference between the highest and the lowest Payment (in US$) in Congo (Democratic)?
Provide a short and direct response. 1.59e+08. What is the difference between the highest and the lowest Payment (in US$) of Dominican Republic?
Make the answer very short. 7.43e+08. What is the difference between the highest and the lowest Payment (in US$) of Solomon Islands?
Make the answer very short. 2.12e+07. 